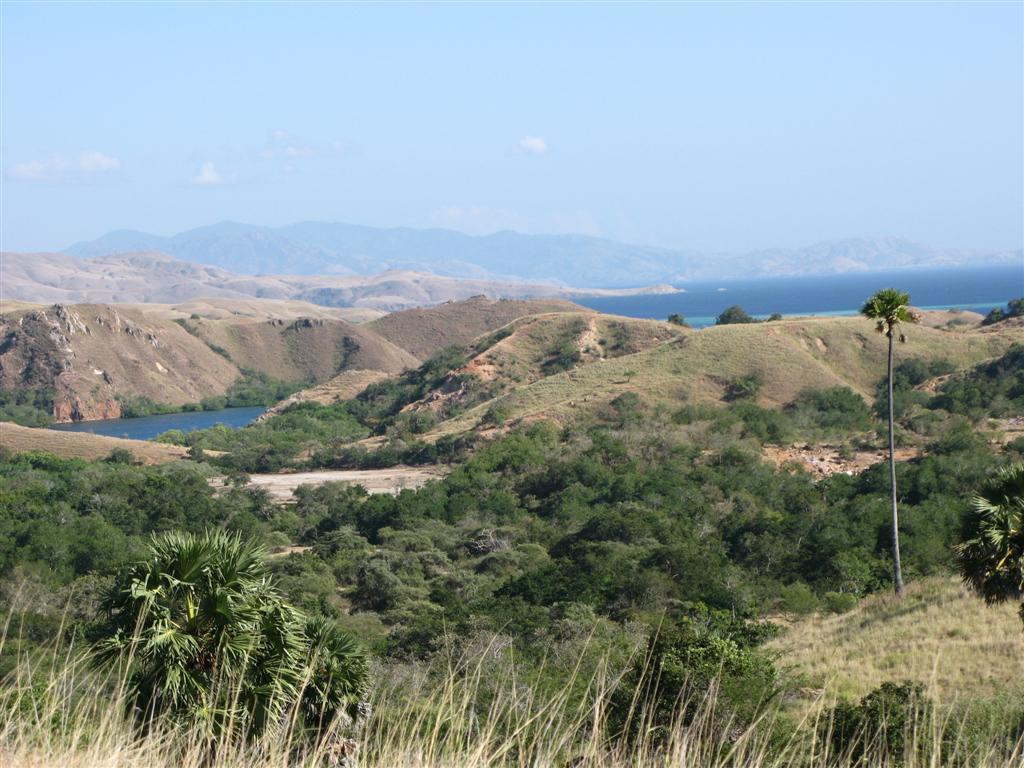What type of vegetation can be seen in the image? There is grass, plants, and trees in the image. What natural features are present in the image? There are mountains and a river in the image. What part of the natural environment is visible in the image? The sky is visible in the image. What direction is the paper blowing in the image? There is no paper present in the image, so it cannot be determined which direction it would be blowing. 